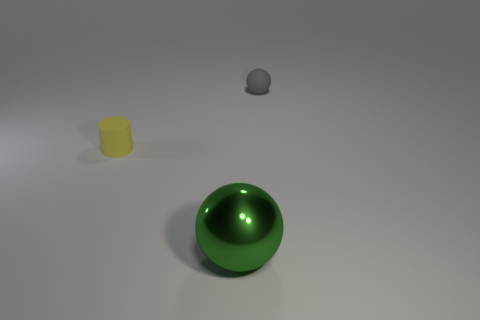Add 1 tiny cyan shiny blocks. How many objects exist? 4 Subtract all cylinders. How many objects are left? 2 Subtract 0 yellow spheres. How many objects are left? 3 Subtract all gray cubes. Subtract all yellow objects. How many objects are left? 2 Add 3 metal things. How many metal things are left? 4 Add 2 brown rubber blocks. How many brown rubber blocks exist? 2 